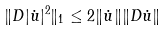Convert formula to latex. <formula><loc_0><loc_0><loc_500><loc_500>\| D | \dot { u } | ^ { 2 } \| _ { 1 } \leq 2 \| \dot { u } \| \| D \dot { u } \|</formula> 